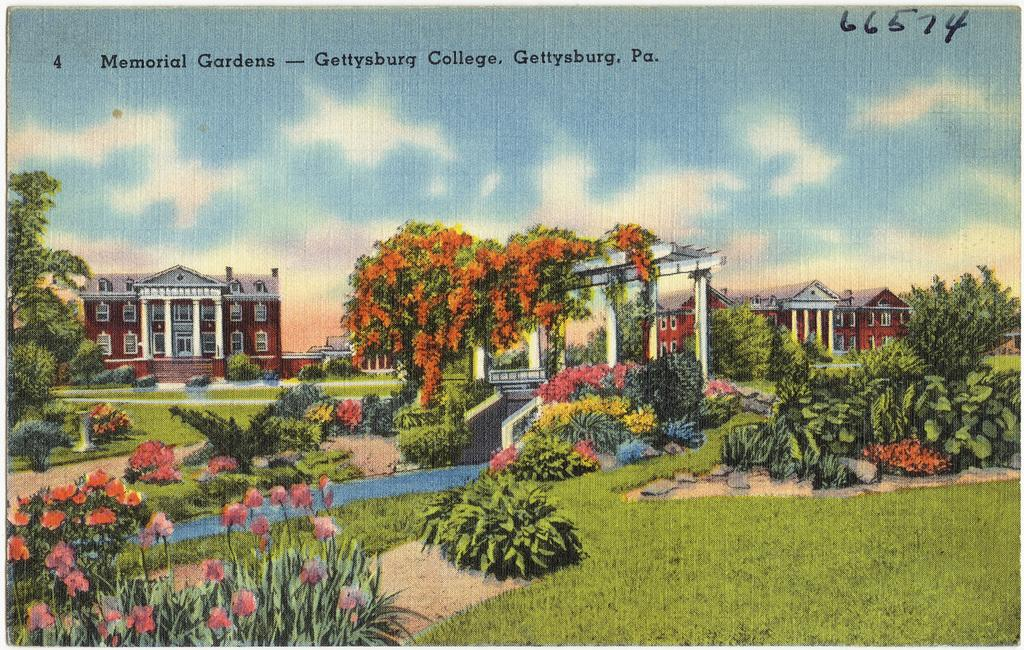What is the main subject of the image? The image contains a picture. What type of structures can be seen in the picture? There are buildings in the picture. What type of vegetation is present in the picture? Bushes, plants, shrubs, and creepers are visible in the picture. What part of the natural environment is visible in the picture? The ground and the sky are visible in the picture. What can be seen in the sky? Clouds are present in the sky. What type of cake is being served at the activity in the picture? There is no cake or activity present in the picture; it features a scene with buildings, vegetation, and the sky. 